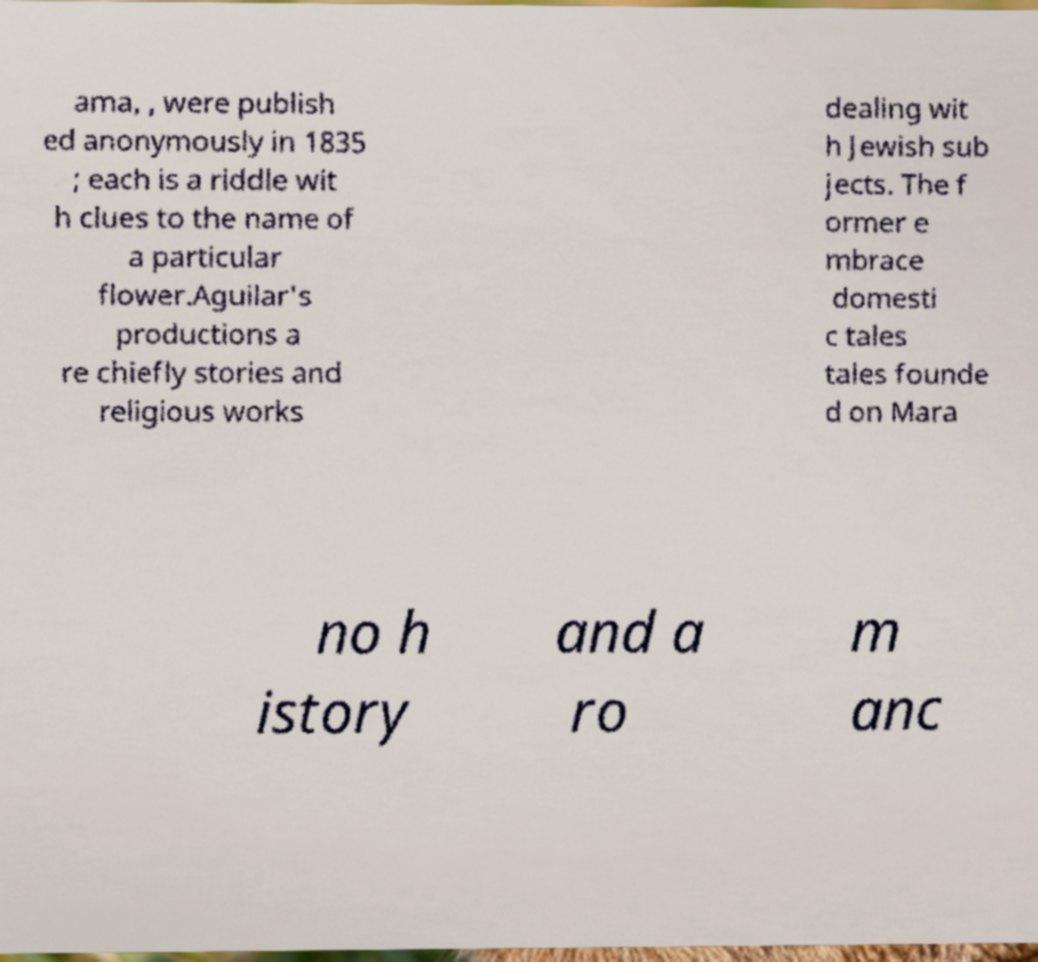Please read and relay the text visible in this image. What does it say? ama, , were publish ed anonymously in 1835 ; each is a riddle wit h clues to the name of a particular flower.Aguilar's productions a re chiefly stories and religious works dealing wit h Jewish sub jects. The f ormer e mbrace domesti c tales tales founde d on Mara no h istory and a ro m anc 